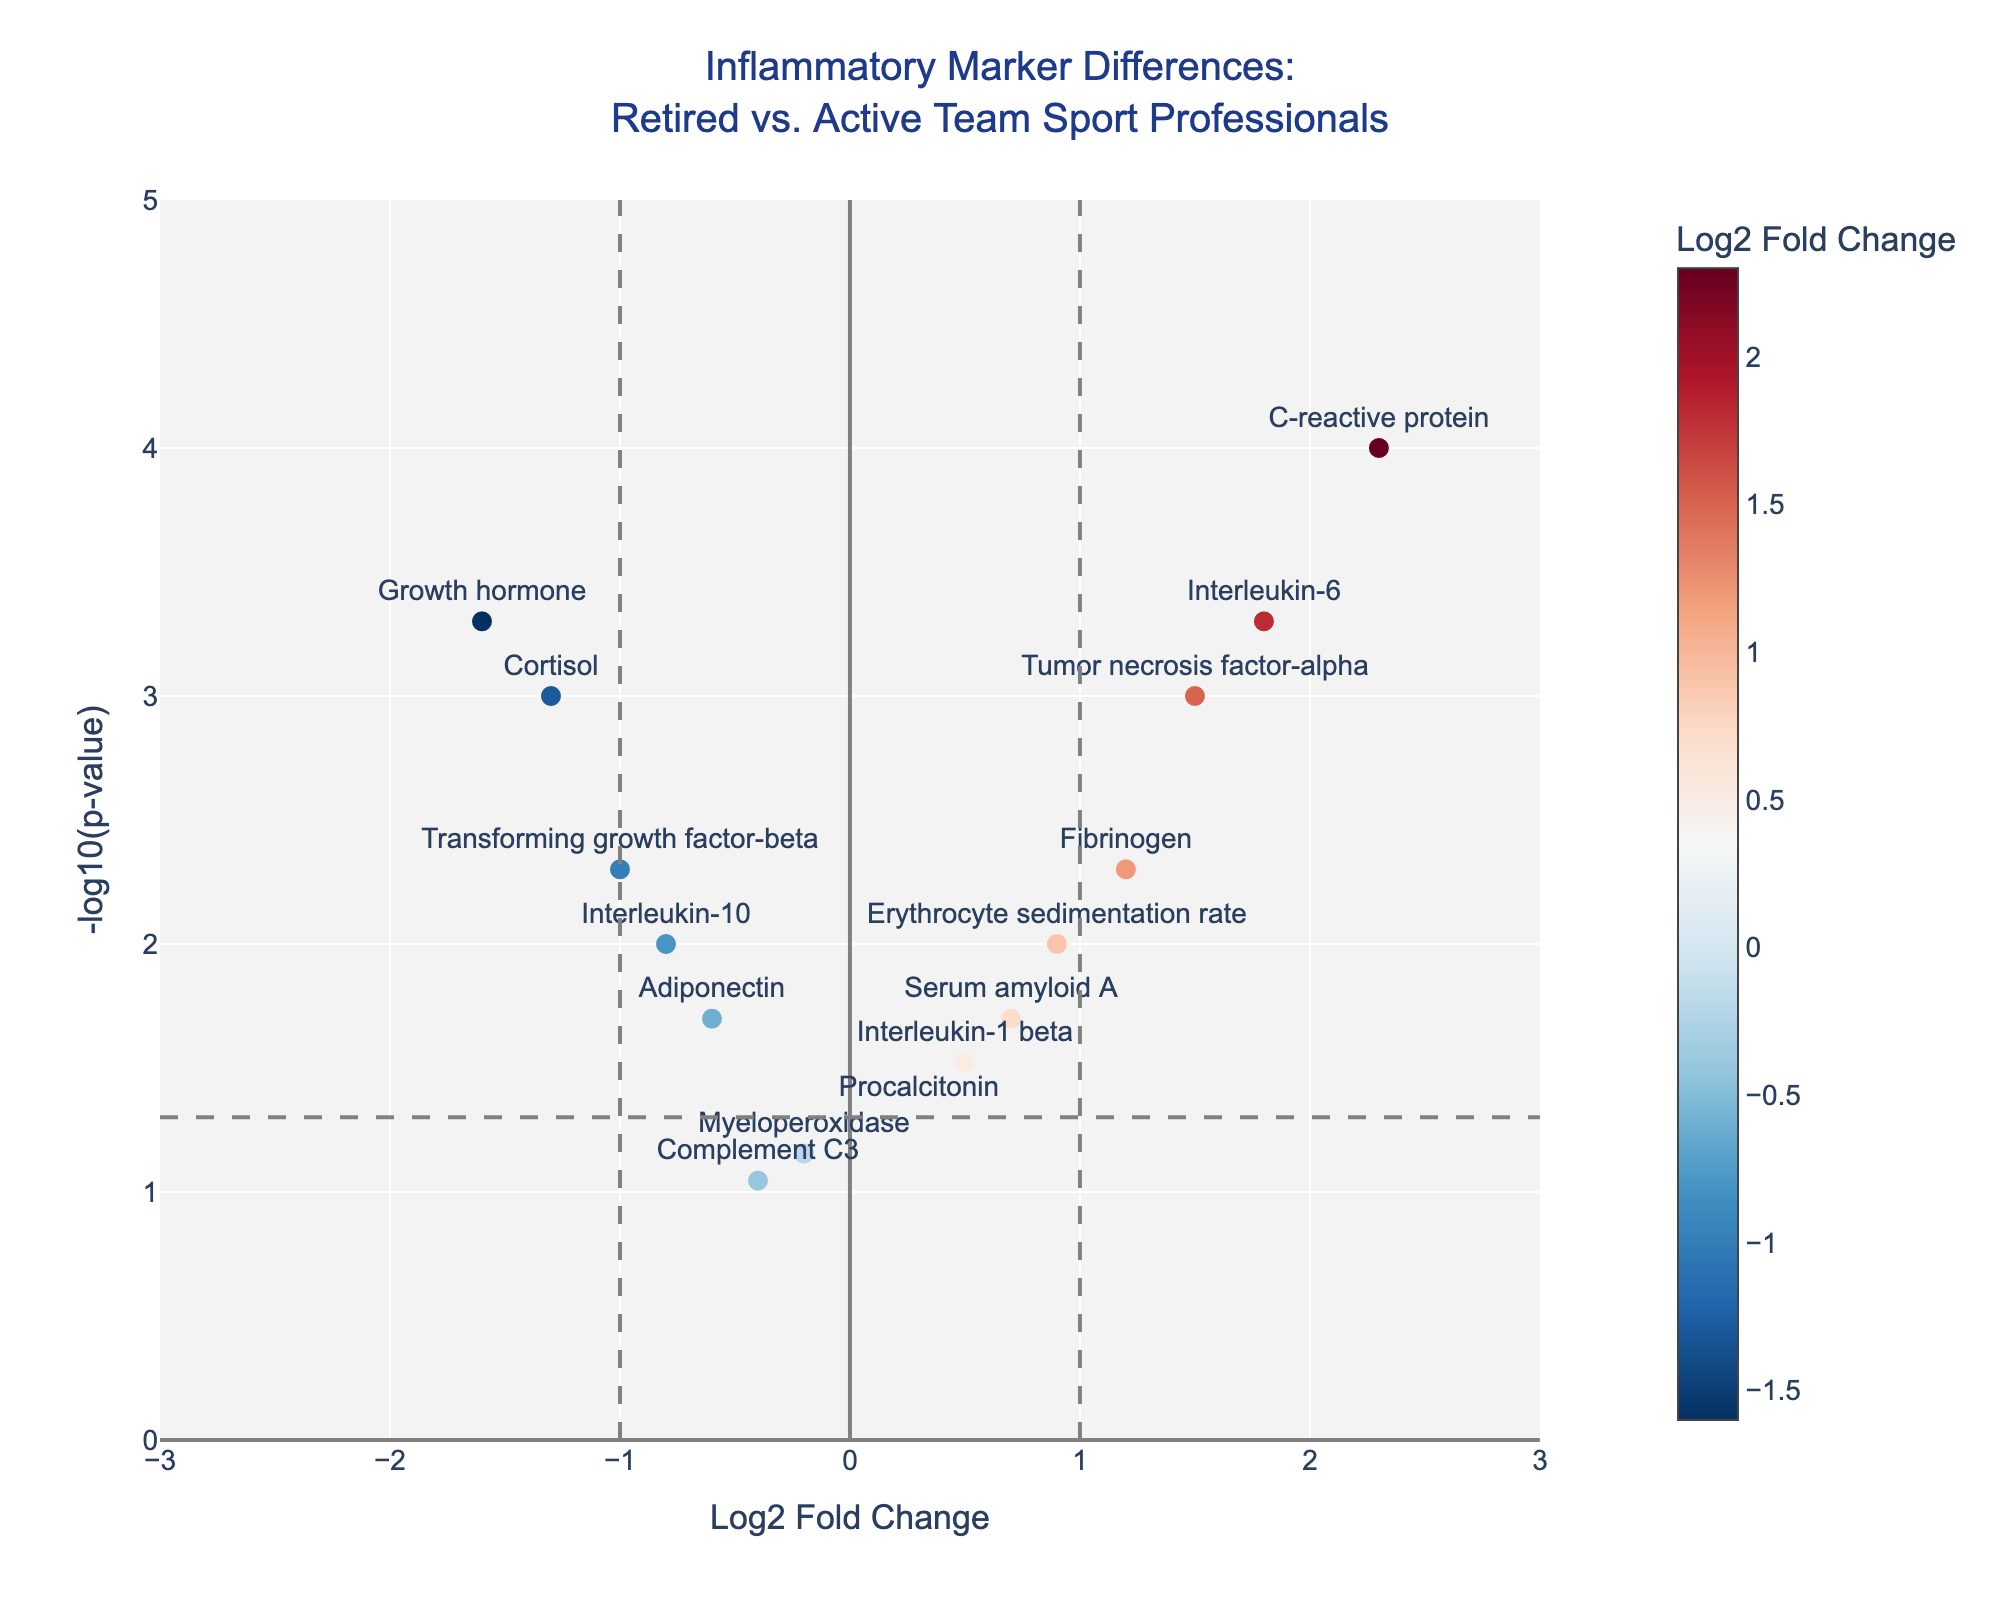What is the title of the figure? The title of the figure is usually found at the top of the plot and gives a summary of what the figure is about. In this case, it reads: "Inflammatory Marker Differences: Retired vs. Active Team Sport Professionals".
Answer: Inflammatory Marker Differences: Retired vs. Active Team Sport Professionals How many data points are there in total? By counting the number of individual markers or points on the scatter plot, you can determine the total number of data points. There are 15 points, one for each protein listed in the data.
Answer: 15 Which proteins have a Log2 Fold Change greater than 1? On the x-axis, locate the proteins that fall to the right of the 1-mark line. These include "C-reactive protein" and "Interleukin-6".
Answer: C-reactive protein, Interleukin-6 What's the significance threshold for the p-value displayed in the figure? The threshold line for the p-value is typically a horizontal dashed line. In this figure, the line is positioned at -log10(0.05), which equals 1.3.
Answer: 0.05 Which protein has the highest -log10(p-value)? Look at the y-axis and find the highest positioned point. This corresponds to "C-reactive protein".
Answer: C-reactive protein Which proteins are considered statistically significant (p<0.05)? Find the points above the -log10(p-value) threshold of 1.3. The proteins are "C-reactive protein", "Interleukin-6", "Tumor necrosis factor-alpha", "Fibrinogen", "Transforming growth factor-beta", "Cortisol", and "Growth hormone".
Answer: C-reactive protein, Interleukin-6, Tumor necrosis factor-alpha, Fibrinogen, Transforming growth factor-beta, Cortisol, Growth hormone What is the range of the Log2 Fold Change values? The range is from the minimum to the maximum Log2 Fold Change values on the x-axis. It spans from -1.6 (Growth hormone) to 2.3 (C-reactive protein).
Answer: -1.6 to 2.3 Which proteins have a Log2 Fold Change less than -1? Locate the proteins positioned to the left of the -1 mark on the x-axis. They are "Transforming growth factor-beta", "Cortisol", and "Growth hormone".
Answer: Transforming growth factor-beta, Cortisol, Growth hormone How does the Log2 Fold Change of "Cortisol" compare to "Interleukin-1 beta"? "Cortisol" has a Log2 Fold Change of -1.3, which is lower than "Interleukin-1 beta", which has a Log2 Fold Change of 0.5.
Answer: Cortisol is lower than Interleukin-1 beta What's the median Log2 Fold Change value of these proteins? First, order the Log2 Fold Change values: -1.6, -1.3, -1, -0.8, -0.6, -0.4, -0.2, 0.3, 0.5, 0.7, 0.9, 1.2, 1.5, 1.8, 2.3. The median is the middle value, which is 0.3.
Answer: 0.3 